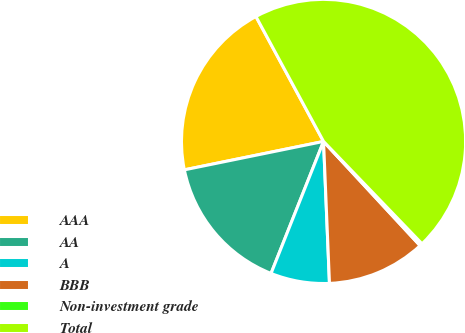Convert chart to OTSL. <chart><loc_0><loc_0><loc_500><loc_500><pie_chart><fcel>AAA<fcel>AA<fcel>A<fcel>BBB<fcel>Non-investment grade<fcel>Total<nl><fcel>20.31%<fcel>15.77%<fcel>6.69%<fcel>11.23%<fcel>0.3%<fcel>45.7%<nl></chart> 